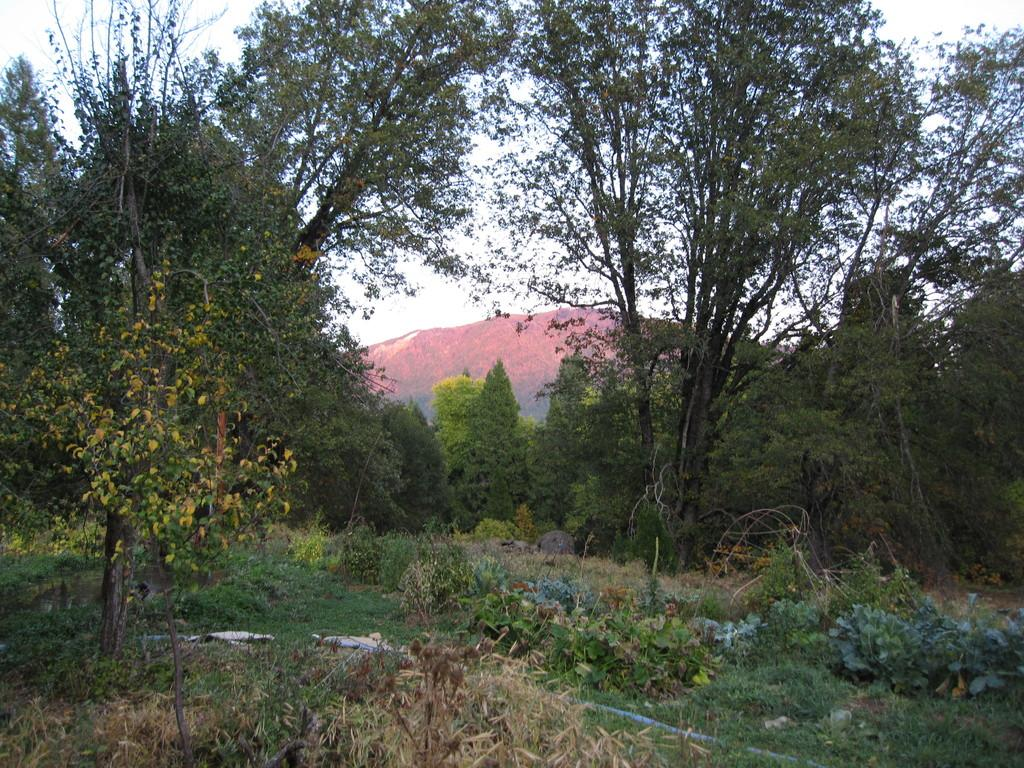What type of vegetation can be seen in the image? There are trees in the image. What geographical feature is present in the image? There is a hill in the image. How many bells are hanging from the trees in the image? There are no bells present in the image; it only features trees and a hill. 